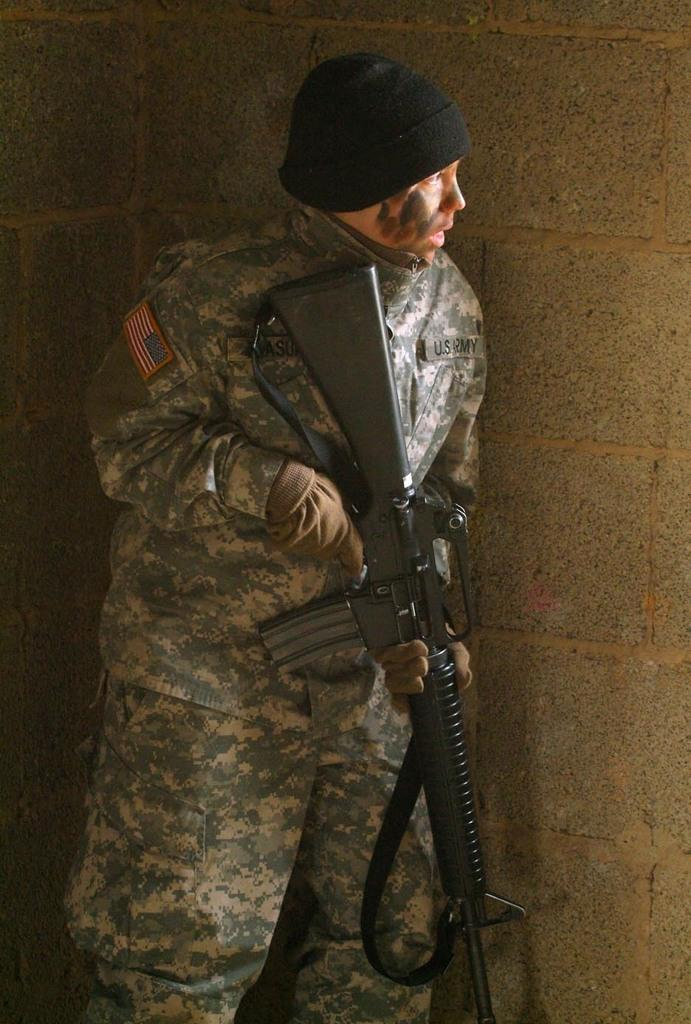Who is present in the image? There is a man in the image. What is the man doing in the image? The man is standing in the image. What object is the man holding in the image? The man is holding a gun in the image. What can be seen in the background of the image? There is a wall in the background of the image. What is the man wearing on his head? The man is wearing a cap on his head. What type of mint can be seen growing on the man's mouth in the image? There is no mint or any plant growing on the man's mouth in the image. What is the man using the cushion for in the image? A: There is no cushion present in the image. 